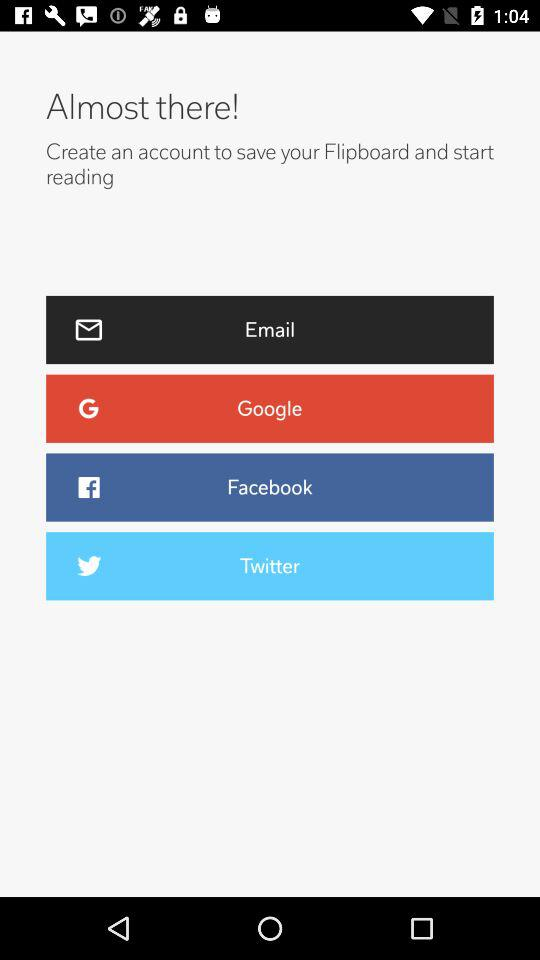How many social media options are there?
Answer the question using a single word or phrase. 4 